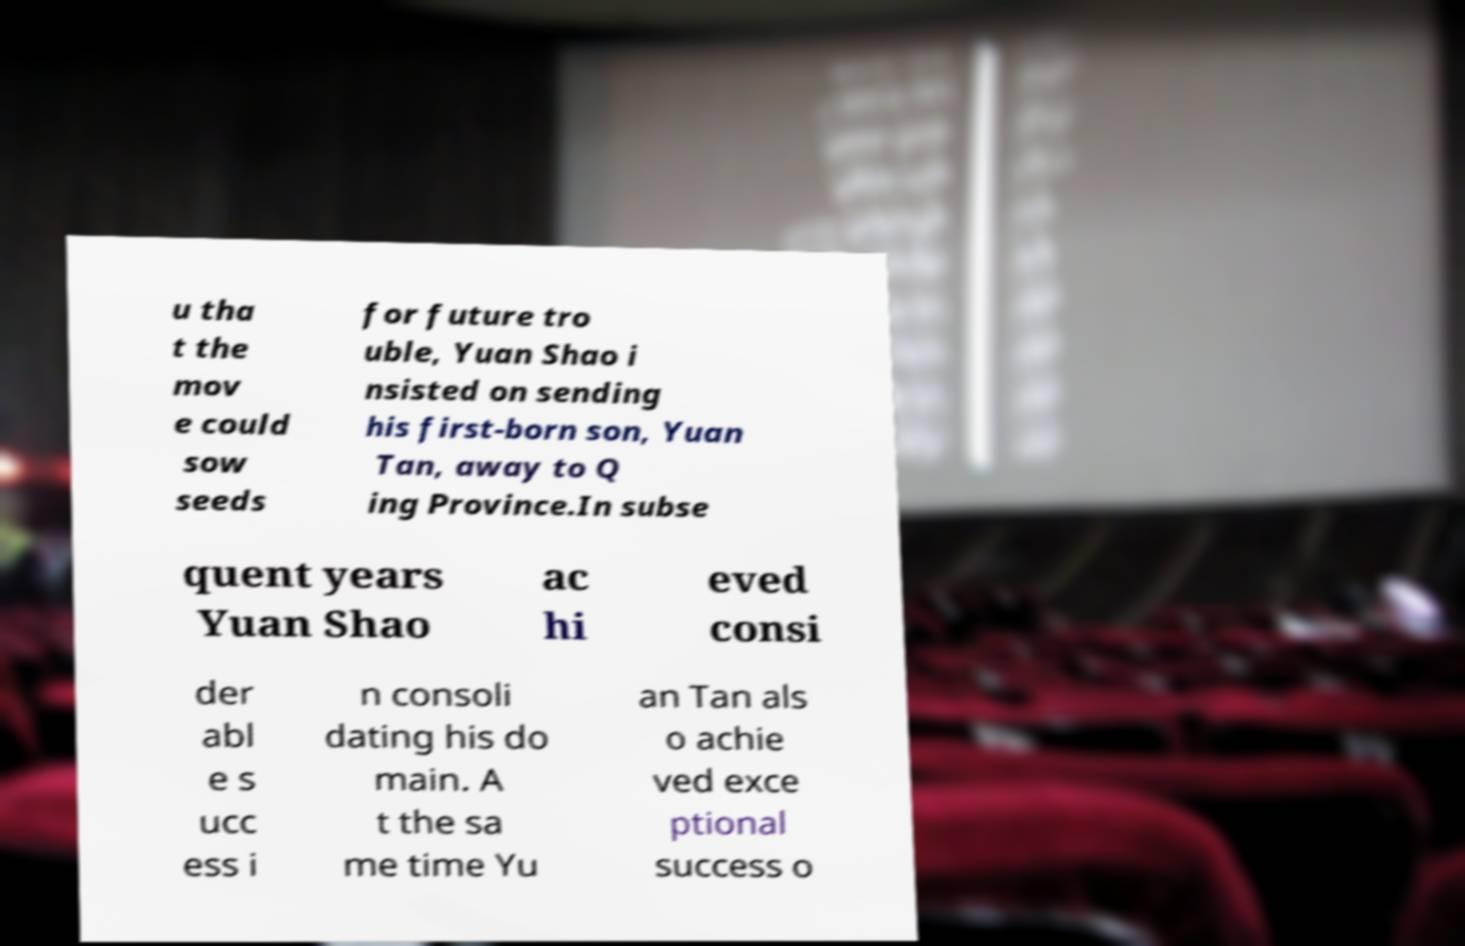There's text embedded in this image that I need extracted. Can you transcribe it verbatim? u tha t the mov e could sow seeds for future tro uble, Yuan Shao i nsisted on sending his first-born son, Yuan Tan, away to Q ing Province.In subse quent years Yuan Shao ac hi eved consi der abl e s ucc ess i n consoli dating his do main. A t the sa me time Yu an Tan als o achie ved exce ptional success o 